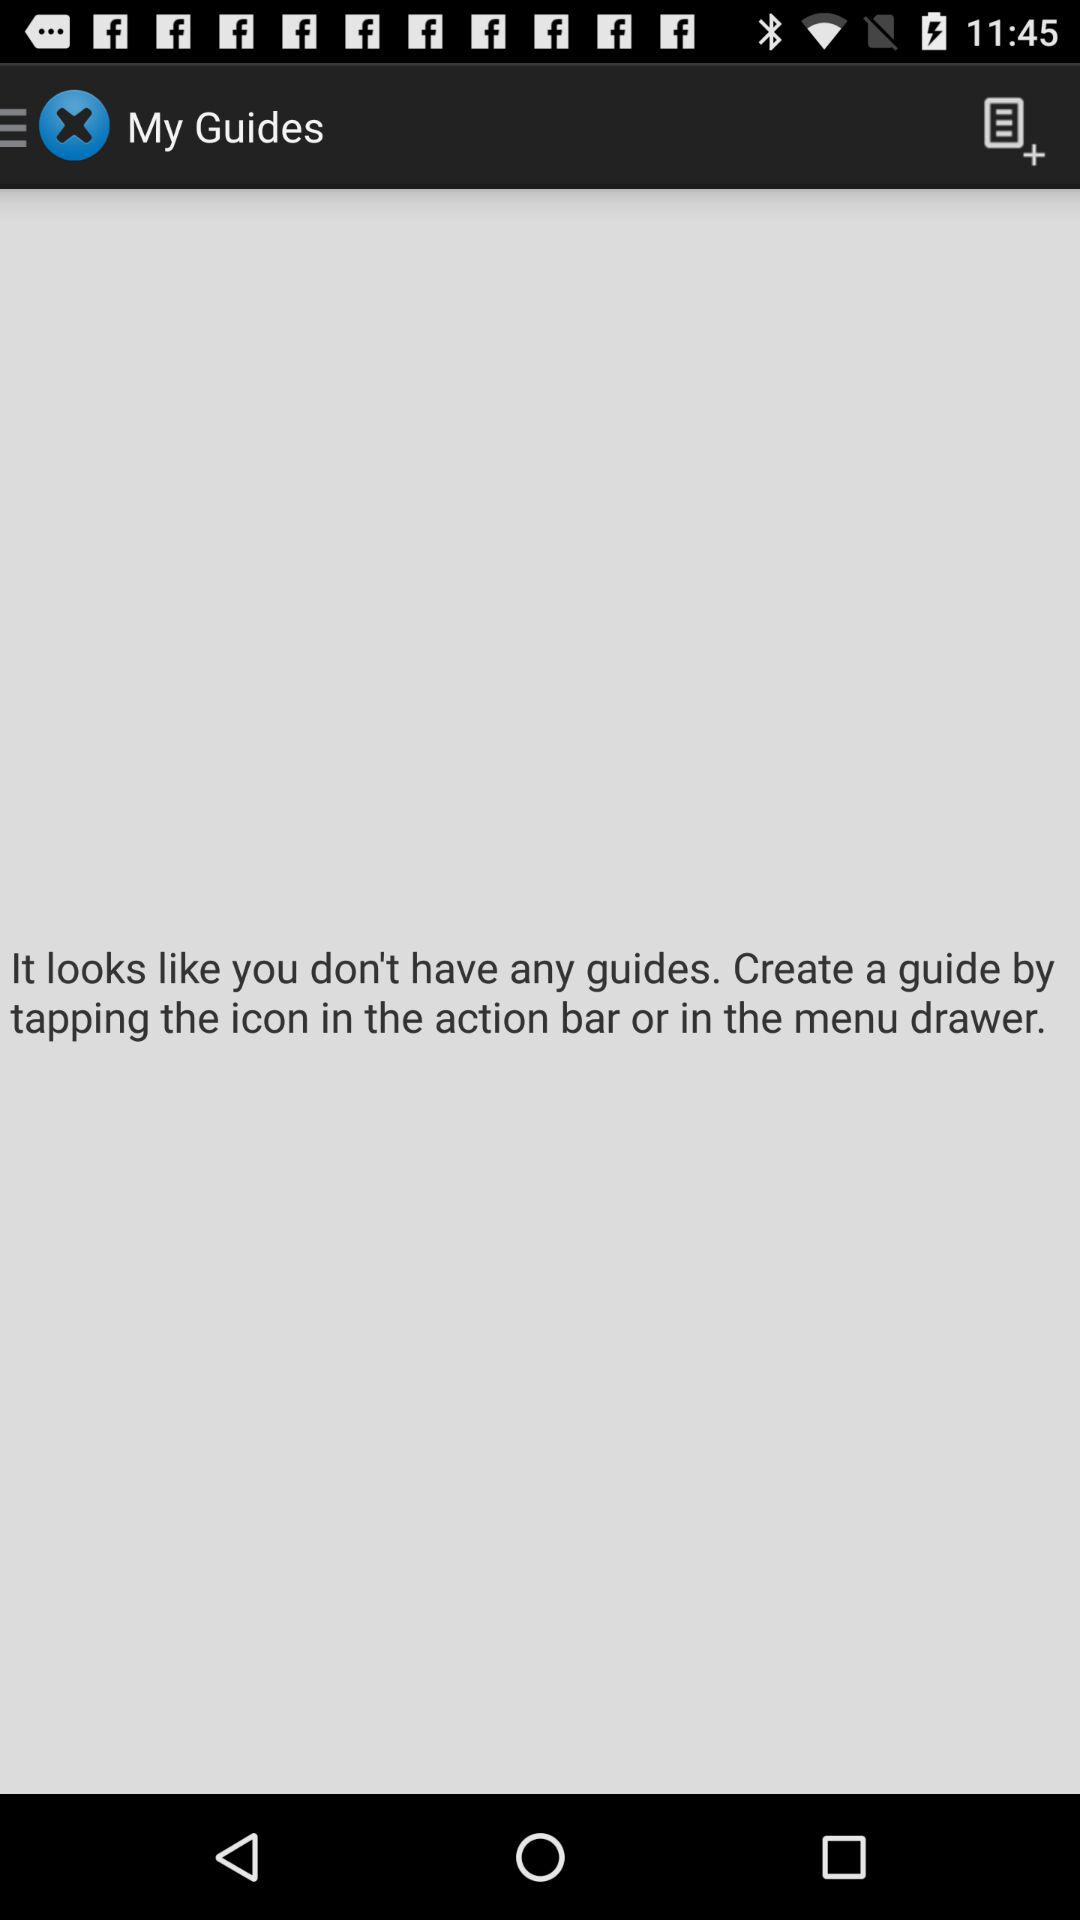What is the application name? The application name is "My Guides". 